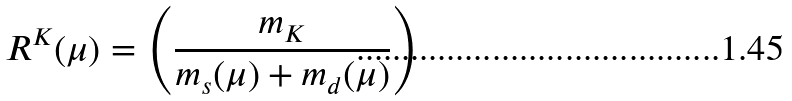<formula> <loc_0><loc_0><loc_500><loc_500>R ^ { K } ( \mu ) = \left ( \frac { m _ { K } } { m _ { s } ( \mu ) + m _ { d } ( \mu ) } \right )</formula> 